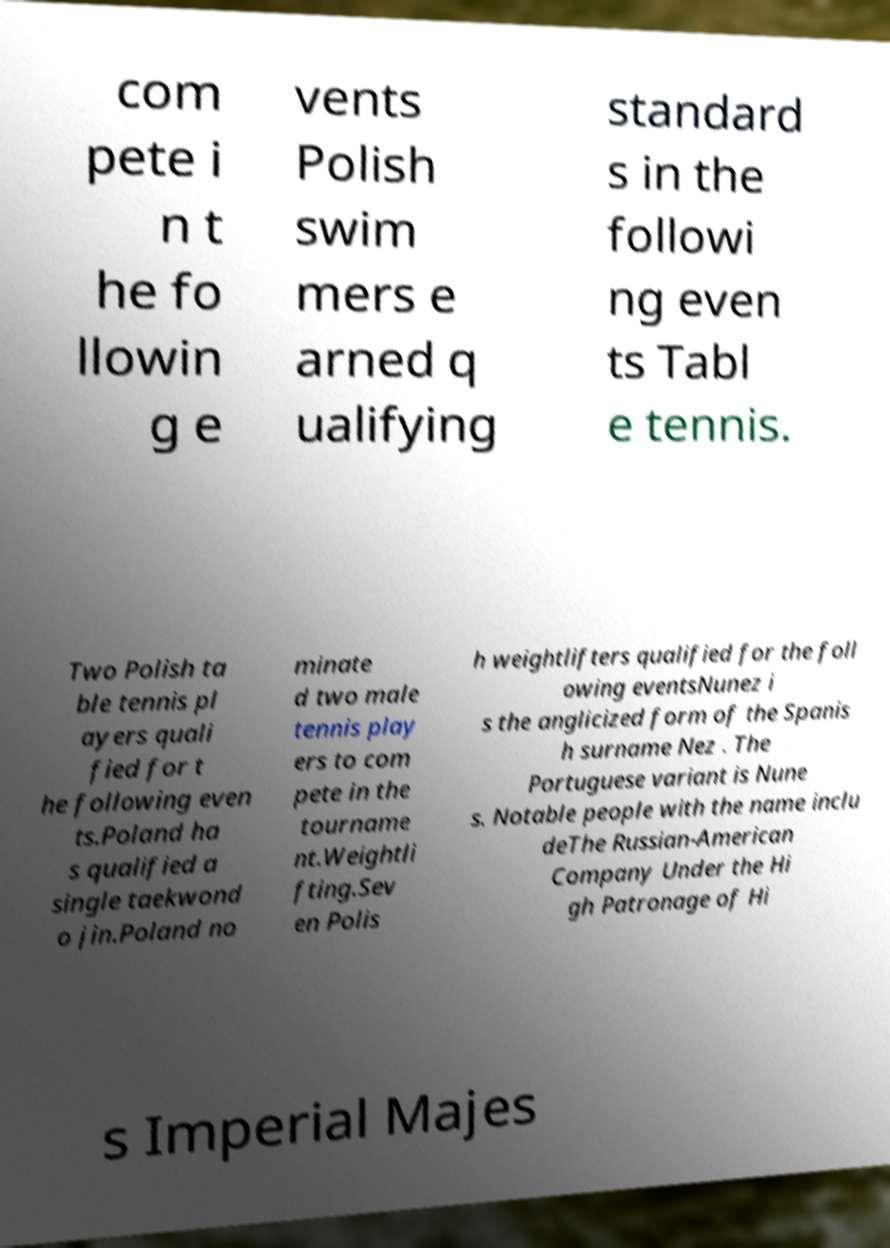What messages or text are displayed in this image? I need them in a readable, typed format. com pete i n t he fo llowin g e vents Polish swim mers e arned q ualifying standard s in the followi ng even ts Tabl e tennis. Two Polish ta ble tennis pl ayers quali fied for t he following even ts.Poland ha s qualified a single taekwond o jin.Poland no minate d two male tennis play ers to com pete in the tourname nt.Weightli fting.Sev en Polis h weightlifters qualified for the foll owing eventsNunez i s the anglicized form of the Spanis h surname Nez . The Portuguese variant is Nune s. Notable people with the name inclu deThe Russian-American Company Under the Hi gh Patronage of Hi s Imperial Majes 